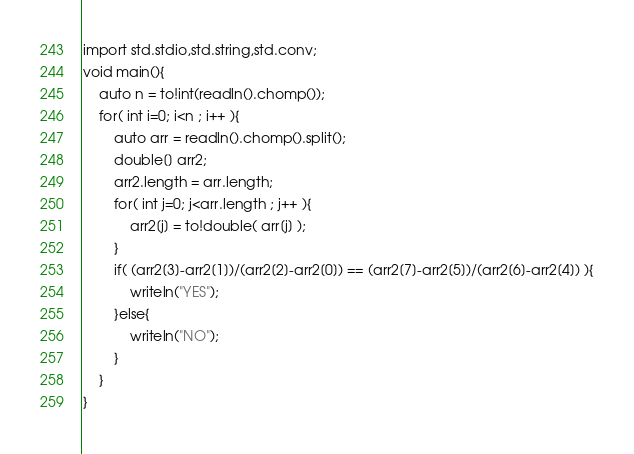Convert code to text. <code><loc_0><loc_0><loc_500><loc_500><_D_>import std.stdio,std.string,std.conv;
void main(){
	auto n = to!int(readln().chomp());
	for( int i=0; i<n ; i++ ){
		auto arr = readln().chomp().split();
		double[] arr2;
		arr2.length = arr.length;
		for( int j=0; j<arr.length ; j++ ){
			arr2[j] = to!double( arr[j] );
		}
		if( (arr2[3]-arr2[1])/(arr2[2]-arr2[0]) == (arr2[7]-arr2[5])/(arr2[6]-arr2[4]) ){
			writeln("YES");
		}else{
			writeln("NO");
		}
	}
}</code> 